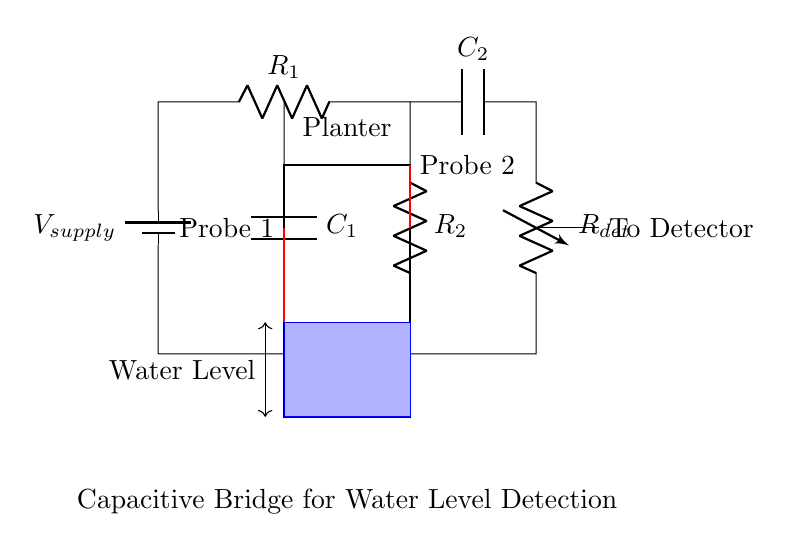What is the supply voltage for this circuit? The supply voltage is labeled as \( V_{supply} \) in the circuit diagram, indicating the source of power for the circuit.
Answer: \( V_{supply} \) What type of capacitors are used in this bridge circuit? The diagram shows two capacitors labeled \( C_1 \) and \( C_2 \). Both are part of the capacitive bridge and are essential for measuring the water levels.
Answer: Capacitors What is the purpose of the resistors in this circuit? The resistors \( R_1 \) and \( R_2 \) are used to balance the bridge and help in detecting changes in capacitance due to water level changes, which in turn affects the current through the circuit.
Answer: Balance bridge Where are the probe connections located in the circuit? The probe connections are indicated by thick red lines connecting to points at \( C_1 \) and \( C_2 \), allowing for the measurement of the water level through the capacitive sensing.
Answer: Red lines How does this circuit detect water levels? The circuit detects water levels by measuring the capacitance changes between the probes based on the dielectric properties of water, which affects the capacitance of \( C_1 \) and \( C_2 \).
Answer: Capacitive sensing What happens to the detector output as water levels change? As the water level changes, the capacitance values of \( C_1 \) and \( C_2 \) will vary, resulting in a change in the output signal sent to the detector, indicating the current water level.
Answer: Changes with water level What type of bridge circuit is illustrated here? This is a capacitive bridge circuit, specifically designed for monitoring variations in capacitance due to water levels in the planter, distinguishing it from other types of bridge circuits like resistive bridges.
Answer: Capacitive bridge 